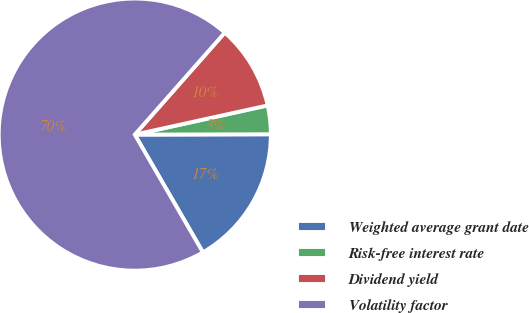Convert chart. <chart><loc_0><loc_0><loc_500><loc_500><pie_chart><fcel>Weighted average grant date<fcel>Risk-free interest rate<fcel>Dividend yield<fcel>Volatility factor<nl><fcel>16.69%<fcel>3.4%<fcel>10.05%<fcel>69.86%<nl></chart> 